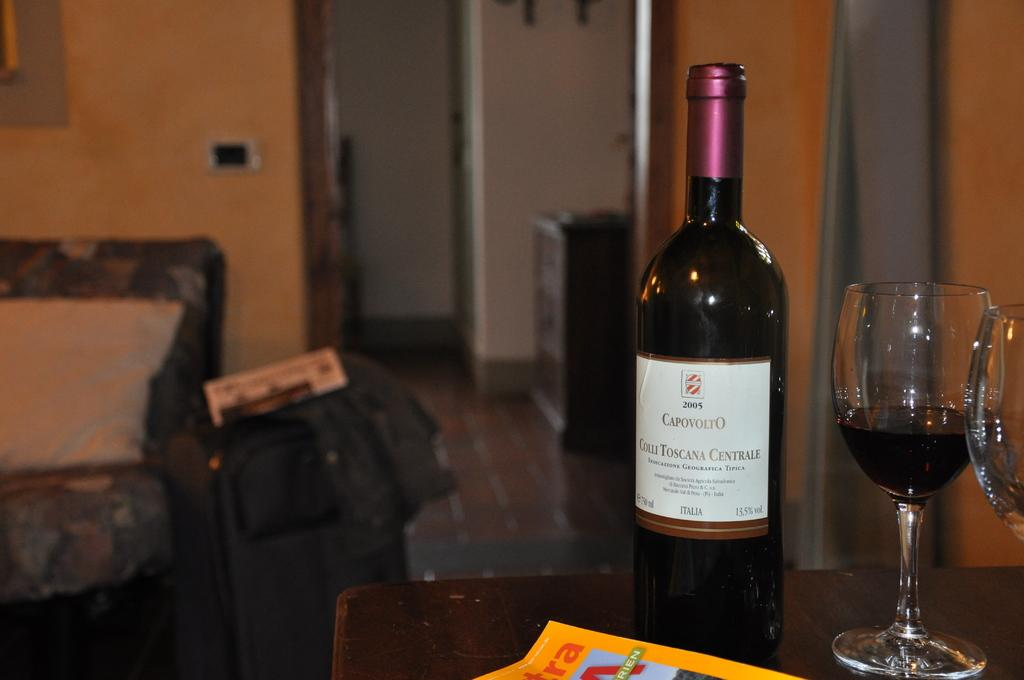<image>
Render a clear and concise summary of the photo. A bottle of Capavolto wine is sitting on a table in a living room. 